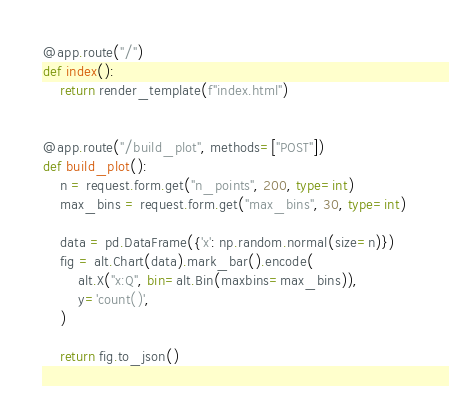<code> <loc_0><loc_0><loc_500><loc_500><_Python_>

@app.route("/")
def index():
    return render_template(f"index.html")


@app.route("/build_plot", methods=["POST"])
def build_plot():
    n = request.form.get("n_points", 200, type=int)
    max_bins = request.form.get("max_bins", 30, type=int)

    data = pd.DataFrame({'x': np.random.normal(size=n)})
    fig = alt.Chart(data).mark_bar().encode(
        alt.X("x:Q", bin=alt.Bin(maxbins=max_bins)),
        y='count()',
    )

    return fig.to_json()
</code> 